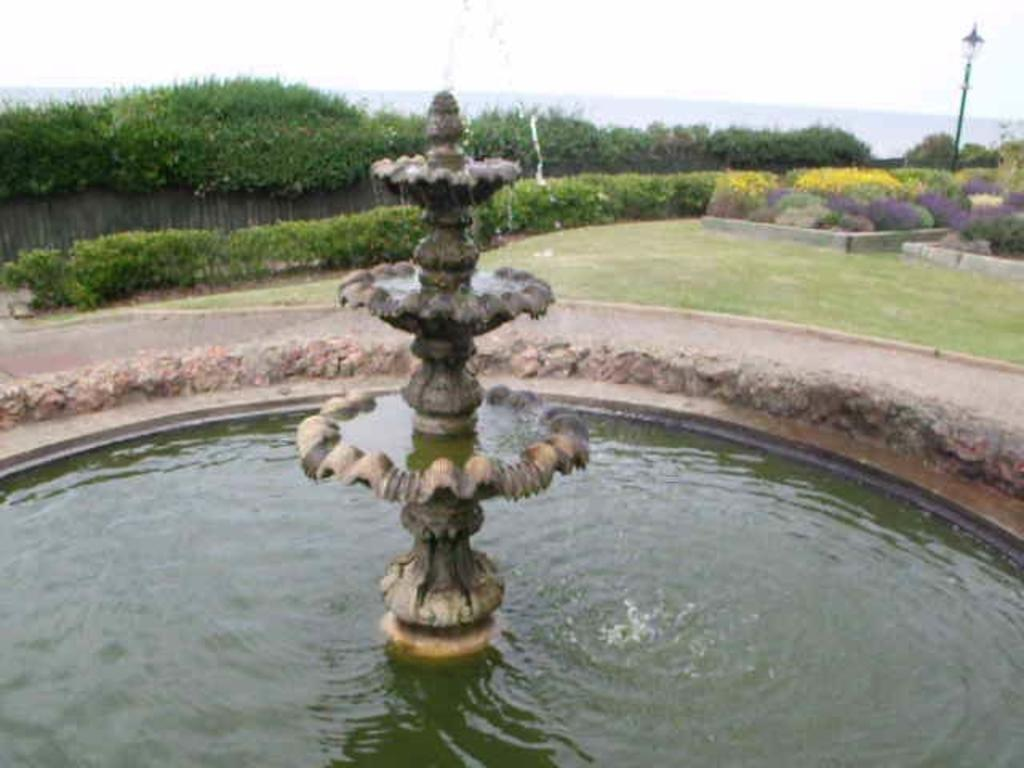What is the main feature in the image? There is a water fountain in the image. What can be seen in the background of the image? In the background, there is a lawn, shrubs, a wooden fence, a light pole, and the sky. What type of vegetation is present in the background? Shrubs are present in the background of the image. What is the purpose of the wooden fence in the image? The wooden fence in the background may serve as a boundary or decoration. Can you see a coil of rice in the water fountain? There is no coil of rice present in the water fountain or the image. 